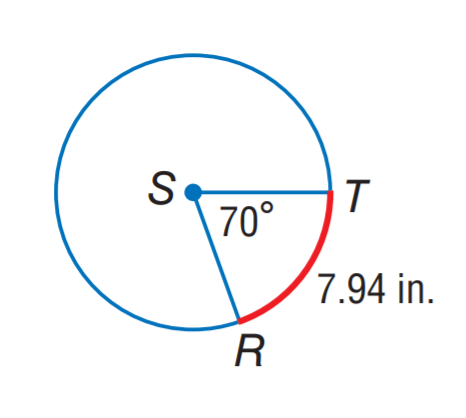Answer the mathemtical geometry problem and directly provide the correct option letter.
Question: Find the circumference of \odot S. Round to the nearest hundredth.
Choices: A: 7.94 B: 20.42 C: 40.83 D: 81.67 C 